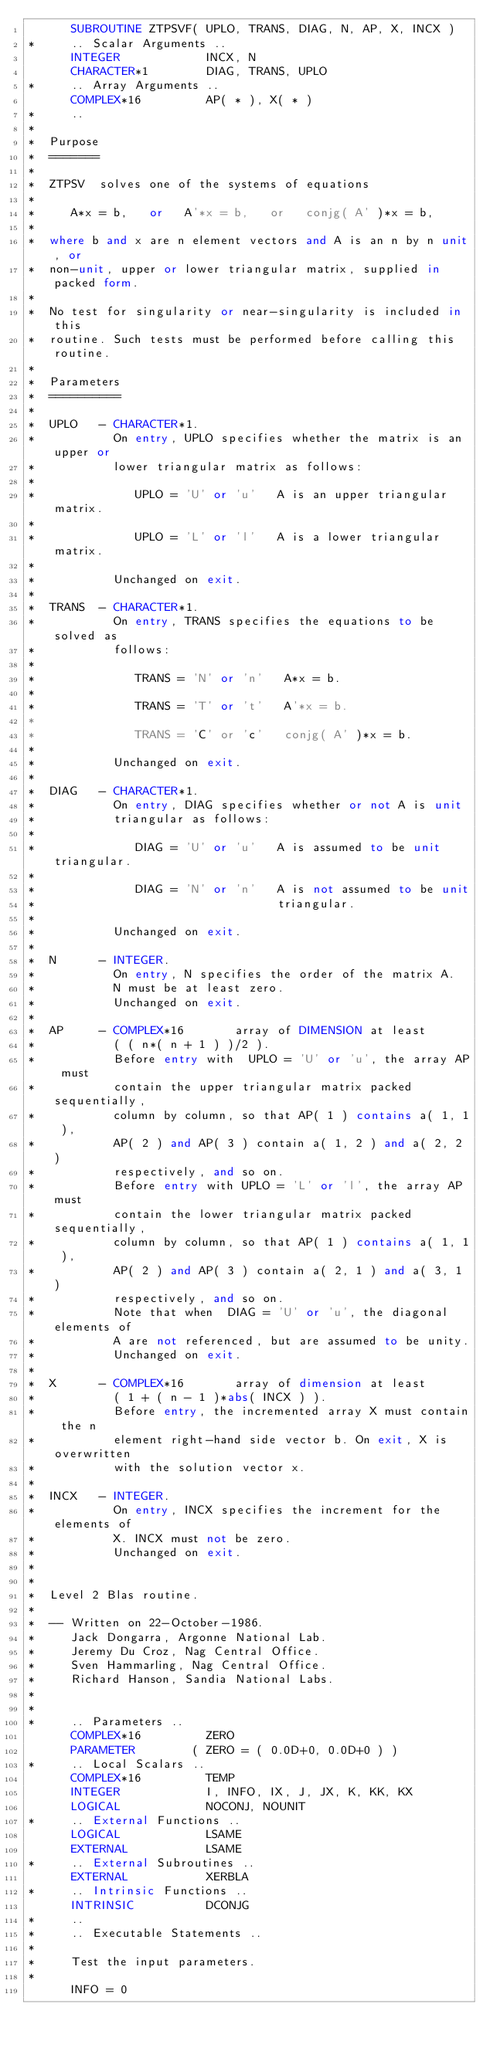<code> <loc_0><loc_0><loc_500><loc_500><_FORTRAN_>      SUBROUTINE ZTPSVF( UPLO, TRANS, DIAG, N, AP, X, INCX )
*     .. Scalar Arguments ..
      INTEGER            INCX, N
      CHARACTER*1        DIAG, TRANS, UPLO
*     .. Array Arguments ..
      COMPLEX*16         AP( * ), X( * )
*     ..
*
*  Purpose
*  =======
*
*  ZTPSV  solves one of the systems of equations
*
*     A*x = b,   or   A'*x = b,   or   conjg( A' )*x = b,
*
*  where b and x are n element vectors and A is an n by n unit, or
*  non-unit, upper or lower triangular matrix, supplied in packed form.
*
*  No test for singularity or near-singularity is included in this
*  routine. Such tests must be performed before calling this routine.
*
*  Parameters
*  ==========
*
*  UPLO   - CHARACTER*1.
*           On entry, UPLO specifies whether the matrix is an upper or
*           lower triangular matrix as follows:
*
*              UPLO = 'U' or 'u'   A is an upper triangular matrix.
*
*              UPLO = 'L' or 'l'   A is a lower triangular matrix.
*
*           Unchanged on exit.
*
*  TRANS  - CHARACTER*1.
*           On entry, TRANS specifies the equations to be solved as
*           follows:
*
*              TRANS = 'N' or 'n'   A*x = b.
*
*              TRANS = 'T' or 't'   A'*x = b.
*
*              TRANS = 'C' or 'c'   conjg( A' )*x = b.
*
*           Unchanged on exit.
*
*  DIAG   - CHARACTER*1.
*           On entry, DIAG specifies whether or not A is unit
*           triangular as follows:
*
*              DIAG = 'U' or 'u'   A is assumed to be unit triangular.
*
*              DIAG = 'N' or 'n'   A is not assumed to be unit
*                                  triangular.
*
*           Unchanged on exit.
*
*  N      - INTEGER.
*           On entry, N specifies the order of the matrix A.
*           N must be at least zero.
*           Unchanged on exit.
*
*  AP     - COMPLEX*16       array of DIMENSION at least
*           ( ( n*( n + 1 ) )/2 ).
*           Before entry with  UPLO = 'U' or 'u', the array AP must
*           contain the upper triangular matrix packed sequentially,
*           column by column, so that AP( 1 ) contains a( 1, 1 ),
*           AP( 2 ) and AP( 3 ) contain a( 1, 2 ) and a( 2, 2 )
*           respectively, and so on.
*           Before entry with UPLO = 'L' or 'l', the array AP must
*           contain the lower triangular matrix packed sequentially,
*           column by column, so that AP( 1 ) contains a( 1, 1 ),
*           AP( 2 ) and AP( 3 ) contain a( 2, 1 ) and a( 3, 1 )
*           respectively, and so on.
*           Note that when  DIAG = 'U' or 'u', the diagonal elements of
*           A are not referenced, but are assumed to be unity.
*           Unchanged on exit.
*
*  X      - COMPLEX*16       array of dimension at least
*           ( 1 + ( n - 1 )*abs( INCX ) ).
*           Before entry, the incremented array X must contain the n
*           element right-hand side vector b. On exit, X is overwritten
*           with the solution vector x.
*
*  INCX   - INTEGER.
*           On entry, INCX specifies the increment for the elements of
*           X. INCX must not be zero.
*           Unchanged on exit.
*
*
*  Level 2 Blas routine.
*
*  -- Written on 22-October-1986.
*     Jack Dongarra, Argonne National Lab.
*     Jeremy Du Croz, Nag Central Office.
*     Sven Hammarling, Nag Central Office.
*     Richard Hanson, Sandia National Labs.
*
*
*     .. Parameters ..
      COMPLEX*16         ZERO
      PARAMETER        ( ZERO = ( 0.0D+0, 0.0D+0 ) )
*     .. Local Scalars ..
      COMPLEX*16         TEMP
      INTEGER            I, INFO, IX, J, JX, K, KK, KX
      LOGICAL            NOCONJ, NOUNIT
*     .. External Functions ..
      LOGICAL            LSAME
      EXTERNAL           LSAME
*     .. External Subroutines ..
      EXTERNAL           XERBLA
*     .. Intrinsic Functions ..
      INTRINSIC          DCONJG
*     ..
*     .. Executable Statements ..
*
*     Test the input parameters.
*
      INFO = 0</code> 